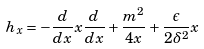Convert formula to latex. <formula><loc_0><loc_0><loc_500><loc_500>h _ { x } = - \frac { d } { d x } x \frac { d } { d x } + \frac { m ^ { 2 } } { 4 x } + \frac { \epsilon } { 2 \delta ^ { 2 } } x</formula> 